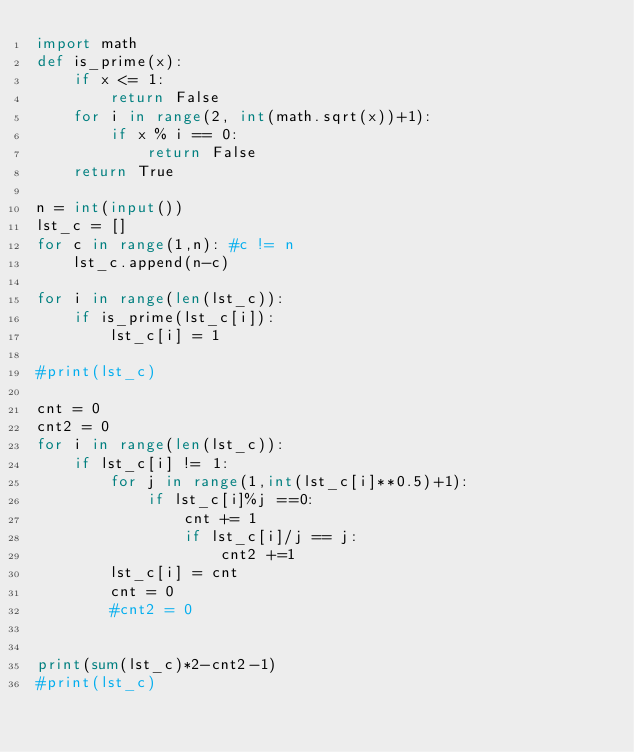Convert code to text. <code><loc_0><loc_0><loc_500><loc_500><_Python_>import math
def is_prime(x):
    if x <= 1:
        return False
    for i in range(2, int(math.sqrt(x))+1):
        if x % i == 0:
            return False
    return True

n = int(input())
lst_c = []
for c in range(1,n): #c != n
    lst_c.append(n-c)

for i in range(len(lst_c)):
    if is_prime(lst_c[i]):
        lst_c[i] = 1

#print(lst_c)

cnt = 0
cnt2 = 0
for i in range(len(lst_c)):
    if lst_c[i] != 1:
        for j in range(1,int(lst_c[i]**0.5)+1):
            if lst_c[i]%j ==0:
                cnt += 1
                if lst_c[i]/j == j:
                    cnt2 +=1
        lst_c[i] = cnt
        cnt = 0
        #cnt2 = 0


print(sum(lst_c)*2-cnt2-1)
#print(lst_c)</code> 